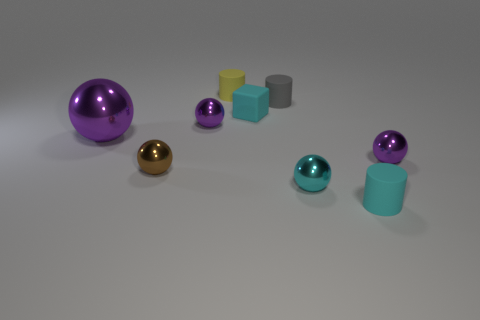Subtract all purple cylinders. How many purple spheres are left? 3 Subtract 1 spheres. How many spheres are left? 4 Subtract all brown balls. How many balls are left? 4 Subtract all small cyan spheres. How many spheres are left? 4 Add 1 cyan rubber cylinders. How many objects exist? 10 Subtract all balls. How many objects are left? 4 Subtract all big gray shiny cubes. Subtract all yellow objects. How many objects are left? 8 Add 5 cyan rubber cylinders. How many cyan rubber cylinders are left? 6 Add 5 cyan balls. How many cyan balls exist? 6 Subtract 0 blue blocks. How many objects are left? 9 